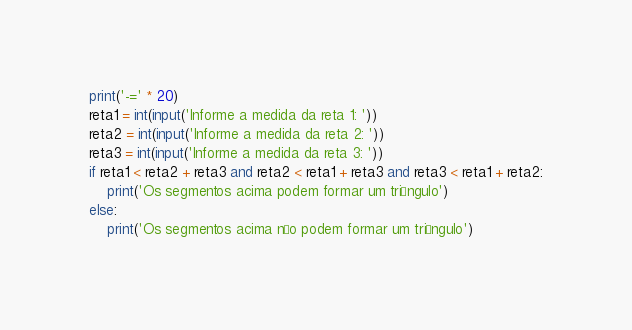<code> <loc_0><loc_0><loc_500><loc_500><_Python_>print('-=' * 20)
reta1 = int(input('Informe a medida da reta 1: '))
reta2 = int(input('Informe a medida da reta 2: '))
reta3 = int(input('Informe a medida da reta 3: '))
if reta1 < reta2 + reta3 and reta2 < reta1 + reta3 and reta3 < reta1 + reta2:
    print('Os segmentos acima podem formar um triângulo')
else:
    print('Os segmentos acima não podem formar um triângulo')
</code> 